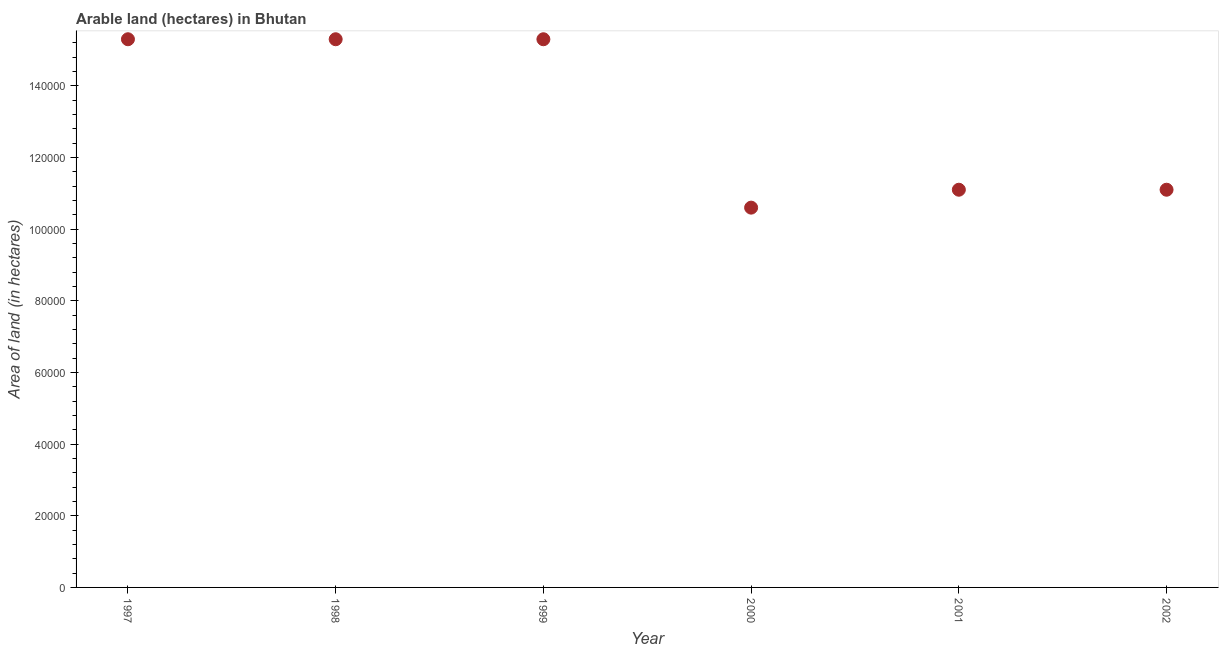What is the area of land in 1999?
Your answer should be very brief. 1.53e+05. Across all years, what is the maximum area of land?
Provide a short and direct response. 1.53e+05. Across all years, what is the minimum area of land?
Make the answer very short. 1.06e+05. In which year was the area of land maximum?
Offer a very short reply. 1997. In which year was the area of land minimum?
Your answer should be compact. 2000. What is the sum of the area of land?
Offer a terse response. 7.87e+05. What is the difference between the area of land in 1999 and 2001?
Your answer should be very brief. 4.20e+04. What is the average area of land per year?
Offer a very short reply. 1.31e+05. What is the median area of land?
Provide a short and direct response. 1.32e+05. Do a majority of the years between 1999 and 2000 (inclusive) have area of land greater than 52000 hectares?
Offer a terse response. Yes. Is the sum of the area of land in 1997 and 2002 greater than the maximum area of land across all years?
Ensure brevity in your answer.  Yes. What is the difference between the highest and the lowest area of land?
Give a very brief answer. 4.70e+04. In how many years, is the area of land greater than the average area of land taken over all years?
Make the answer very short. 3. Does the area of land monotonically increase over the years?
Your answer should be very brief. No. Are the values on the major ticks of Y-axis written in scientific E-notation?
Give a very brief answer. No. Does the graph contain grids?
Ensure brevity in your answer.  No. What is the title of the graph?
Provide a succinct answer. Arable land (hectares) in Bhutan. What is the label or title of the Y-axis?
Give a very brief answer. Area of land (in hectares). What is the Area of land (in hectares) in 1997?
Offer a very short reply. 1.53e+05. What is the Area of land (in hectares) in 1998?
Your response must be concise. 1.53e+05. What is the Area of land (in hectares) in 1999?
Your response must be concise. 1.53e+05. What is the Area of land (in hectares) in 2000?
Your response must be concise. 1.06e+05. What is the Area of land (in hectares) in 2001?
Make the answer very short. 1.11e+05. What is the Area of land (in hectares) in 2002?
Your response must be concise. 1.11e+05. What is the difference between the Area of land (in hectares) in 1997 and 1998?
Offer a very short reply. 0. What is the difference between the Area of land (in hectares) in 1997 and 2000?
Your answer should be compact. 4.70e+04. What is the difference between the Area of land (in hectares) in 1997 and 2001?
Your answer should be compact. 4.20e+04. What is the difference between the Area of land (in hectares) in 1997 and 2002?
Offer a very short reply. 4.20e+04. What is the difference between the Area of land (in hectares) in 1998 and 1999?
Provide a short and direct response. 0. What is the difference between the Area of land (in hectares) in 1998 and 2000?
Offer a terse response. 4.70e+04. What is the difference between the Area of land (in hectares) in 1998 and 2001?
Offer a terse response. 4.20e+04. What is the difference between the Area of land (in hectares) in 1998 and 2002?
Provide a short and direct response. 4.20e+04. What is the difference between the Area of land (in hectares) in 1999 and 2000?
Offer a very short reply. 4.70e+04. What is the difference between the Area of land (in hectares) in 1999 and 2001?
Your answer should be very brief. 4.20e+04. What is the difference between the Area of land (in hectares) in 1999 and 2002?
Offer a very short reply. 4.20e+04. What is the difference between the Area of land (in hectares) in 2000 and 2001?
Provide a succinct answer. -5000. What is the difference between the Area of land (in hectares) in 2000 and 2002?
Your answer should be very brief. -5000. What is the ratio of the Area of land (in hectares) in 1997 to that in 2000?
Give a very brief answer. 1.44. What is the ratio of the Area of land (in hectares) in 1997 to that in 2001?
Provide a succinct answer. 1.38. What is the ratio of the Area of land (in hectares) in 1997 to that in 2002?
Make the answer very short. 1.38. What is the ratio of the Area of land (in hectares) in 1998 to that in 2000?
Offer a terse response. 1.44. What is the ratio of the Area of land (in hectares) in 1998 to that in 2001?
Ensure brevity in your answer.  1.38. What is the ratio of the Area of land (in hectares) in 1998 to that in 2002?
Give a very brief answer. 1.38. What is the ratio of the Area of land (in hectares) in 1999 to that in 2000?
Keep it short and to the point. 1.44. What is the ratio of the Area of land (in hectares) in 1999 to that in 2001?
Provide a short and direct response. 1.38. What is the ratio of the Area of land (in hectares) in 1999 to that in 2002?
Offer a terse response. 1.38. What is the ratio of the Area of land (in hectares) in 2000 to that in 2001?
Offer a terse response. 0.95. What is the ratio of the Area of land (in hectares) in 2000 to that in 2002?
Your answer should be compact. 0.95. What is the ratio of the Area of land (in hectares) in 2001 to that in 2002?
Your answer should be compact. 1. 